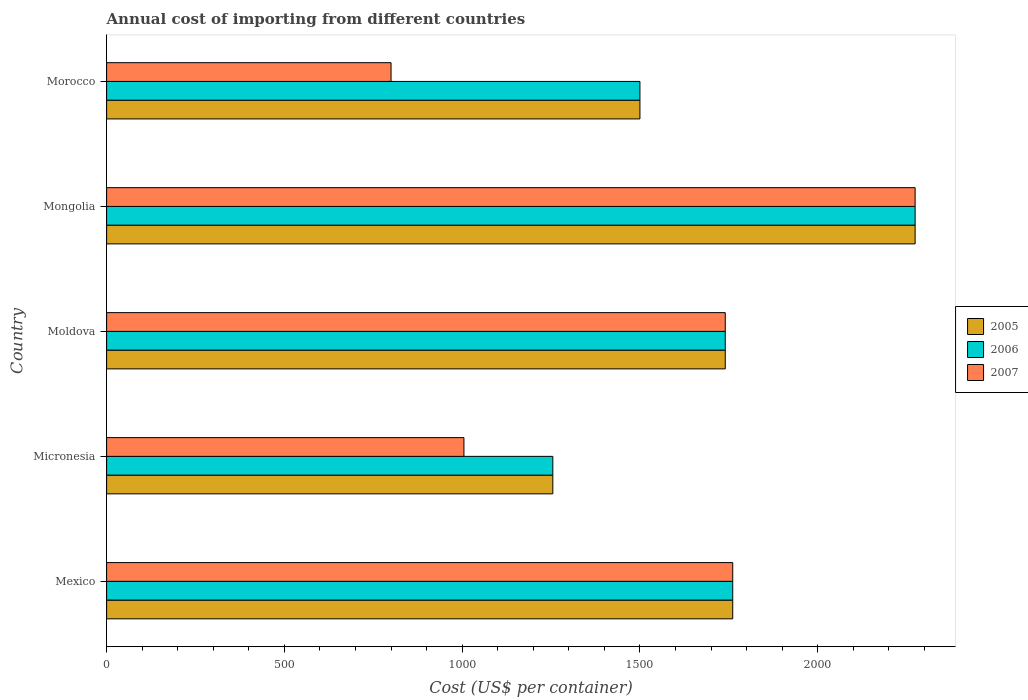How many different coloured bars are there?
Make the answer very short. 3. Are the number of bars per tick equal to the number of legend labels?
Offer a very short reply. Yes. How many bars are there on the 1st tick from the top?
Give a very brief answer. 3. How many bars are there on the 1st tick from the bottom?
Offer a very short reply. 3. What is the total annual cost of importing in 2006 in Mexico?
Offer a very short reply. 1761. Across all countries, what is the maximum total annual cost of importing in 2007?
Give a very brief answer. 2274. Across all countries, what is the minimum total annual cost of importing in 2005?
Give a very brief answer. 1255. In which country was the total annual cost of importing in 2007 maximum?
Offer a very short reply. Mongolia. In which country was the total annual cost of importing in 2005 minimum?
Your answer should be very brief. Micronesia. What is the total total annual cost of importing in 2005 in the graph?
Give a very brief answer. 8530. What is the difference between the total annual cost of importing in 2007 in Mexico and that in Mongolia?
Your answer should be compact. -513. What is the difference between the total annual cost of importing in 2006 in Moldova and the total annual cost of importing in 2007 in Mongolia?
Your answer should be very brief. -534. What is the average total annual cost of importing in 2005 per country?
Provide a short and direct response. 1706. In how many countries, is the total annual cost of importing in 2005 greater than 100 US$?
Ensure brevity in your answer.  5. What is the ratio of the total annual cost of importing in 2007 in Mongolia to that in Morocco?
Provide a succinct answer. 2.84. Is the total annual cost of importing in 2007 in Micronesia less than that in Mongolia?
Give a very brief answer. Yes. What is the difference between the highest and the second highest total annual cost of importing in 2005?
Provide a short and direct response. 513. What is the difference between the highest and the lowest total annual cost of importing in 2005?
Ensure brevity in your answer.  1019. In how many countries, is the total annual cost of importing in 2006 greater than the average total annual cost of importing in 2006 taken over all countries?
Your answer should be very brief. 3. Are all the bars in the graph horizontal?
Your answer should be very brief. Yes. What is the difference between two consecutive major ticks on the X-axis?
Your response must be concise. 500. How many legend labels are there?
Keep it short and to the point. 3. How are the legend labels stacked?
Your answer should be compact. Vertical. What is the title of the graph?
Provide a short and direct response. Annual cost of importing from different countries. What is the label or title of the X-axis?
Make the answer very short. Cost (US$ per container). What is the Cost (US$ per container) of 2005 in Mexico?
Give a very brief answer. 1761. What is the Cost (US$ per container) of 2006 in Mexico?
Ensure brevity in your answer.  1761. What is the Cost (US$ per container) in 2007 in Mexico?
Make the answer very short. 1761. What is the Cost (US$ per container) of 2005 in Micronesia?
Your response must be concise. 1255. What is the Cost (US$ per container) of 2006 in Micronesia?
Make the answer very short. 1255. What is the Cost (US$ per container) of 2007 in Micronesia?
Offer a very short reply. 1005. What is the Cost (US$ per container) of 2005 in Moldova?
Offer a very short reply. 1740. What is the Cost (US$ per container) in 2006 in Moldova?
Ensure brevity in your answer.  1740. What is the Cost (US$ per container) of 2007 in Moldova?
Provide a short and direct response. 1740. What is the Cost (US$ per container) of 2005 in Mongolia?
Offer a terse response. 2274. What is the Cost (US$ per container) of 2006 in Mongolia?
Offer a very short reply. 2274. What is the Cost (US$ per container) in 2007 in Mongolia?
Offer a terse response. 2274. What is the Cost (US$ per container) of 2005 in Morocco?
Give a very brief answer. 1500. What is the Cost (US$ per container) in 2006 in Morocco?
Provide a short and direct response. 1500. What is the Cost (US$ per container) of 2007 in Morocco?
Your answer should be very brief. 800. Across all countries, what is the maximum Cost (US$ per container) in 2005?
Make the answer very short. 2274. Across all countries, what is the maximum Cost (US$ per container) in 2006?
Offer a very short reply. 2274. Across all countries, what is the maximum Cost (US$ per container) of 2007?
Your answer should be compact. 2274. Across all countries, what is the minimum Cost (US$ per container) in 2005?
Provide a succinct answer. 1255. Across all countries, what is the minimum Cost (US$ per container) in 2006?
Provide a short and direct response. 1255. Across all countries, what is the minimum Cost (US$ per container) in 2007?
Offer a terse response. 800. What is the total Cost (US$ per container) in 2005 in the graph?
Your answer should be compact. 8530. What is the total Cost (US$ per container) in 2006 in the graph?
Keep it short and to the point. 8530. What is the total Cost (US$ per container) of 2007 in the graph?
Your answer should be very brief. 7580. What is the difference between the Cost (US$ per container) in 2005 in Mexico and that in Micronesia?
Your answer should be very brief. 506. What is the difference between the Cost (US$ per container) in 2006 in Mexico and that in Micronesia?
Your response must be concise. 506. What is the difference between the Cost (US$ per container) of 2007 in Mexico and that in Micronesia?
Offer a terse response. 756. What is the difference between the Cost (US$ per container) in 2005 in Mexico and that in Moldova?
Give a very brief answer. 21. What is the difference between the Cost (US$ per container) in 2006 in Mexico and that in Moldova?
Make the answer very short. 21. What is the difference between the Cost (US$ per container) of 2005 in Mexico and that in Mongolia?
Keep it short and to the point. -513. What is the difference between the Cost (US$ per container) in 2006 in Mexico and that in Mongolia?
Keep it short and to the point. -513. What is the difference between the Cost (US$ per container) in 2007 in Mexico and that in Mongolia?
Make the answer very short. -513. What is the difference between the Cost (US$ per container) in 2005 in Mexico and that in Morocco?
Give a very brief answer. 261. What is the difference between the Cost (US$ per container) in 2006 in Mexico and that in Morocco?
Make the answer very short. 261. What is the difference between the Cost (US$ per container) in 2007 in Mexico and that in Morocco?
Make the answer very short. 961. What is the difference between the Cost (US$ per container) of 2005 in Micronesia and that in Moldova?
Provide a succinct answer. -485. What is the difference between the Cost (US$ per container) in 2006 in Micronesia and that in Moldova?
Give a very brief answer. -485. What is the difference between the Cost (US$ per container) of 2007 in Micronesia and that in Moldova?
Provide a succinct answer. -735. What is the difference between the Cost (US$ per container) of 2005 in Micronesia and that in Mongolia?
Keep it short and to the point. -1019. What is the difference between the Cost (US$ per container) in 2006 in Micronesia and that in Mongolia?
Offer a terse response. -1019. What is the difference between the Cost (US$ per container) in 2007 in Micronesia and that in Mongolia?
Offer a very short reply. -1269. What is the difference between the Cost (US$ per container) in 2005 in Micronesia and that in Morocco?
Offer a very short reply. -245. What is the difference between the Cost (US$ per container) of 2006 in Micronesia and that in Morocco?
Your answer should be very brief. -245. What is the difference between the Cost (US$ per container) of 2007 in Micronesia and that in Morocco?
Give a very brief answer. 205. What is the difference between the Cost (US$ per container) of 2005 in Moldova and that in Mongolia?
Your answer should be very brief. -534. What is the difference between the Cost (US$ per container) in 2006 in Moldova and that in Mongolia?
Make the answer very short. -534. What is the difference between the Cost (US$ per container) in 2007 in Moldova and that in Mongolia?
Provide a short and direct response. -534. What is the difference between the Cost (US$ per container) in 2005 in Moldova and that in Morocco?
Your answer should be very brief. 240. What is the difference between the Cost (US$ per container) of 2006 in Moldova and that in Morocco?
Ensure brevity in your answer.  240. What is the difference between the Cost (US$ per container) in 2007 in Moldova and that in Morocco?
Offer a terse response. 940. What is the difference between the Cost (US$ per container) in 2005 in Mongolia and that in Morocco?
Your answer should be very brief. 774. What is the difference between the Cost (US$ per container) in 2006 in Mongolia and that in Morocco?
Provide a short and direct response. 774. What is the difference between the Cost (US$ per container) of 2007 in Mongolia and that in Morocco?
Provide a succinct answer. 1474. What is the difference between the Cost (US$ per container) of 2005 in Mexico and the Cost (US$ per container) of 2006 in Micronesia?
Keep it short and to the point. 506. What is the difference between the Cost (US$ per container) of 2005 in Mexico and the Cost (US$ per container) of 2007 in Micronesia?
Your answer should be compact. 756. What is the difference between the Cost (US$ per container) in 2006 in Mexico and the Cost (US$ per container) in 2007 in Micronesia?
Your answer should be very brief. 756. What is the difference between the Cost (US$ per container) in 2005 in Mexico and the Cost (US$ per container) in 2006 in Moldova?
Give a very brief answer. 21. What is the difference between the Cost (US$ per container) of 2005 in Mexico and the Cost (US$ per container) of 2006 in Mongolia?
Keep it short and to the point. -513. What is the difference between the Cost (US$ per container) in 2005 in Mexico and the Cost (US$ per container) in 2007 in Mongolia?
Provide a short and direct response. -513. What is the difference between the Cost (US$ per container) of 2006 in Mexico and the Cost (US$ per container) of 2007 in Mongolia?
Your answer should be compact. -513. What is the difference between the Cost (US$ per container) in 2005 in Mexico and the Cost (US$ per container) in 2006 in Morocco?
Make the answer very short. 261. What is the difference between the Cost (US$ per container) of 2005 in Mexico and the Cost (US$ per container) of 2007 in Morocco?
Make the answer very short. 961. What is the difference between the Cost (US$ per container) of 2006 in Mexico and the Cost (US$ per container) of 2007 in Morocco?
Keep it short and to the point. 961. What is the difference between the Cost (US$ per container) of 2005 in Micronesia and the Cost (US$ per container) of 2006 in Moldova?
Provide a succinct answer. -485. What is the difference between the Cost (US$ per container) of 2005 in Micronesia and the Cost (US$ per container) of 2007 in Moldova?
Give a very brief answer. -485. What is the difference between the Cost (US$ per container) in 2006 in Micronesia and the Cost (US$ per container) in 2007 in Moldova?
Provide a short and direct response. -485. What is the difference between the Cost (US$ per container) of 2005 in Micronesia and the Cost (US$ per container) of 2006 in Mongolia?
Make the answer very short. -1019. What is the difference between the Cost (US$ per container) in 2005 in Micronesia and the Cost (US$ per container) in 2007 in Mongolia?
Give a very brief answer. -1019. What is the difference between the Cost (US$ per container) in 2006 in Micronesia and the Cost (US$ per container) in 2007 in Mongolia?
Your answer should be compact. -1019. What is the difference between the Cost (US$ per container) of 2005 in Micronesia and the Cost (US$ per container) of 2006 in Morocco?
Your answer should be very brief. -245. What is the difference between the Cost (US$ per container) of 2005 in Micronesia and the Cost (US$ per container) of 2007 in Morocco?
Your response must be concise. 455. What is the difference between the Cost (US$ per container) of 2006 in Micronesia and the Cost (US$ per container) of 2007 in Morocco?
Give a very brief answer. 455. What is the difference between the Cost (US$ per container) of 2005 in Moldova and the Cost (US$ per container) of 2006 in Mongolia?
Provide a succinct answer. -534. What is the difference between the Cost (US$ per container) of 2005 in Moldova and the Cost (US$ per container) of 2007 in Mongolia?
Your response must be concise. -534. What is the difference between the Cost (US$ per container) in 2006 in Moldova and the Cost (US$ per container) in 2007 in Mongolia?
Provide a short and direct response. -534. What is the difference between the Cost (US$ per container) of 2005 in Moldova and the Cost (US$ per container) of 2006 in Morocco?
Offer a very short reply. 240. What is the difference between the Cost (US$ per container) in 2005 in Moldova and the Cost (US$ per container) in 2007 in Morocco?
Make the answer very short. 940. What is the difference between the Cost (US$ per container) in 2006 in Moldova and the Cost (US$ per container) in 2007 in Morocco?
Offer a very short reply. 940. What is the difference between the Cost (US$ per container) in 2005 in Mongolia and the Cost (US$ per container) in 2006 in Morocco?
Your answer should be very brief. 774. What is the difference between the Cost (US$ per container) in 2005 in Mongolia and the Cost (US$ per container) in 2007 in Morocco?
Provide a succinct answer. 1474. What is the difference between the Cost (US$ per container) in 2006 in Mongolia and the Cost (US$ per container) in 2007 in Morocco?
Your answer should be very brief. 1474. What is the average Cost (US$ per container) in 2005 per country?
Your answer should be compact. 1706. What is the average Cost (US$ per container) of 2006 per country?
Your answer should be very brief. 1706. What is the average Cost (US$ per container) of 2007 per country?
Ensure brevity in your answer.  1516. What is the difference between the Cost (US$ per container) of 2005 and Cost (US$ per container) of 2007 in Micronesia?
Keep it short and to the point. 250. What is the difference between the Cost (US$ per container) of 2006 and Cost (US$ per container) of 2007 in Micronesia?
Make the answer very short. 250. What is the difference between the Cost (US$ per container) in 2005 and Cost (US$ per container) in 2007 in Moldova?
Keep it short and to the point. 0. What is the difference between the Cost (US$ per container) in 2006 and Cost (US$ per container) in 2007 in Moldova?
Your response must be concise. 0. What is the difference between the Cost (US$ per container) of 2005 and Cost (US$ per container) of 2007 in Morocco?
Your answer should be compact. 700. What is the difference between the Cost (US$ per container) in 2006 and Cost (US$ per container) in 2007 in Morocco?
Give a very brief answer. 700. What is the ratio of the Cost (US$ per container) in 2005 in Mexico to that in Micronesia?
Provide a succinct answer. 1.4. What is the ratio of the Cost (US$ per container) of 2006 in Mexico to that in Micronesia?
Your answer should be compact. 1.4. What is the ratio of the Cost (US$ per container) in 2007 in Mexico to that in Micronesia?
Provide a succinct answer. 1.75. What is the ratio of the Cost (US$ per container) of 2005 in Mexico to that in Moldova?
Your answer should be very brief. 1.01. What is the ratio of the Cost (US$ per container) of 2006 in Mexico to that in Moldova?
Offer a terse response. 1.01. What is the ratio of the Cost (US$ per container) of 2007 in Mexico to that in Moldova?
Your answer should be compact. 1.01. What is the ratio of the Cost (US$ per container) of 2005 in Mexico to that in Mongolia?
Give a very brief answer. 0.77. What is the ratio of the Cost (US$ per container) of 2006 in Mexico to that in Mongolia?
Make the answer very short. 0.77. What is the ratio of the Cost (US$ per container) in 2007 in Mexico to that in Mongolia?
Offer a terse response. 0.77. What is the ratio of the Cost (US$ per container) of 2005 in Mexico to that in Morocco?
Provide a short and direct response. 1.17. What is the ratio of the Cost (US$ per container) of 2006 in Mexico to that in Morocco?
Ensure brevity in your answer.  1.17. What is the ratio of the Cost (US$ per container) of 2007 in Mexico to that in Morocco?
Your response must be concise. 2.2. What is the ratio of the Cost (US$ per container) of 2005 in Micronesia to that in Moldova?
Your answer should be very brief. 0.72. What is the ratio of the Cost (US$ per container) in 2006 in Micronesia to that in Moldova?
Offer a very short reply. 0.72. What is the ratio of the Cost (US$ per container) of 2007 in Micronesia to that in Moldova?
Keep it short and to the point. 0.58. What is the ratio of the Cost (US$ per container) of 2005 in Micronesia to that in Mongolia?
Make the answer very short. 0.55. What is the ratio of the Cost (US$ per container) of 2006 in Micronesia to that in Mongolia?
Your answer should be very brief. 0.55. What is the ratio of the Cost (US$ per container) in 2007 in Micronesia to that in Mongolia?
Offer a terse response. 0.44. What is the ratio of the Cost (US$ per container) of 2005 in Micronesia to that in Morocco?
Your answer should be very brief. 0.84. What is the ratio of the Cost (US$ per container) of 2006 in Micronesia to that in Morocco?
Your answer should be very brief. 0.84. What is the ratio of the Cost (US$ per container) of 2007 in Micronesia to that in Morocco?
Provide a succinct answer. 1.26. What is the ratio of the Cost (US$ per container) of 2005 in Moldova to that in Mongolia?
Offer a terse response. 0.77. What is the ratio of the Cost (US$ per container) in 2006 in Moldova to that in Mongolia?
Offer a terse response. 0.77. What is the ratio of the Cost (US$ per container) in 2007 in Moldova to that in Mongolia?
Your answer should be compact. 0.77. What is the ratio of the Cost (US$ per container) in 2005 in Moldova to that in Morocco?
Give a very brief answer. 1.16. What is the ratio of the Cost (US$ per container) of 2006 in Moldova to that in Morocco?
Your response must be concise. 1.16. What is the ratio of the Cost (US$ per container) of 2007 in Moldova to that in Morocco?
Your answer should be compact. 2.17. What is the ratio of the Cost (US$ per container) in 2005 in Mongolia to that in Morocco?
Your answer should be compact. 1.52. What is the ratio of the Cost (US$ per container) in 2006 in Mongolia to that in Morocco?
Your answer should be compact. 1.52. What is the ratio of the Cost (US$ per container) in 2007 in Mongolia to that in Morocco?
Make the answer very short. 2.84. What is the difference between the highest and the second highest Cost (US$ per container) of 2005?
Provide a short and direct response. 513. What is the difference between the highest and the second highest Cost (US$ per container) in 2006?
Give a very brief answer. 513. What is the difference between the highest and the second highest Cost (US$ per container) in 2007?
Your response must be concise. 513. What is the difference between the highest and the lowest Cost (US$ per container) in 2005?
Give a very brief answer. 1019. What is the difference between the highest and the lowest Cost (US$ per container) of 2006?
Offer a terse response. 1019. What is the difference between the highest and the lowest Cost (US$ per container) in 2007?
Provide a succinct answer. 1474. 